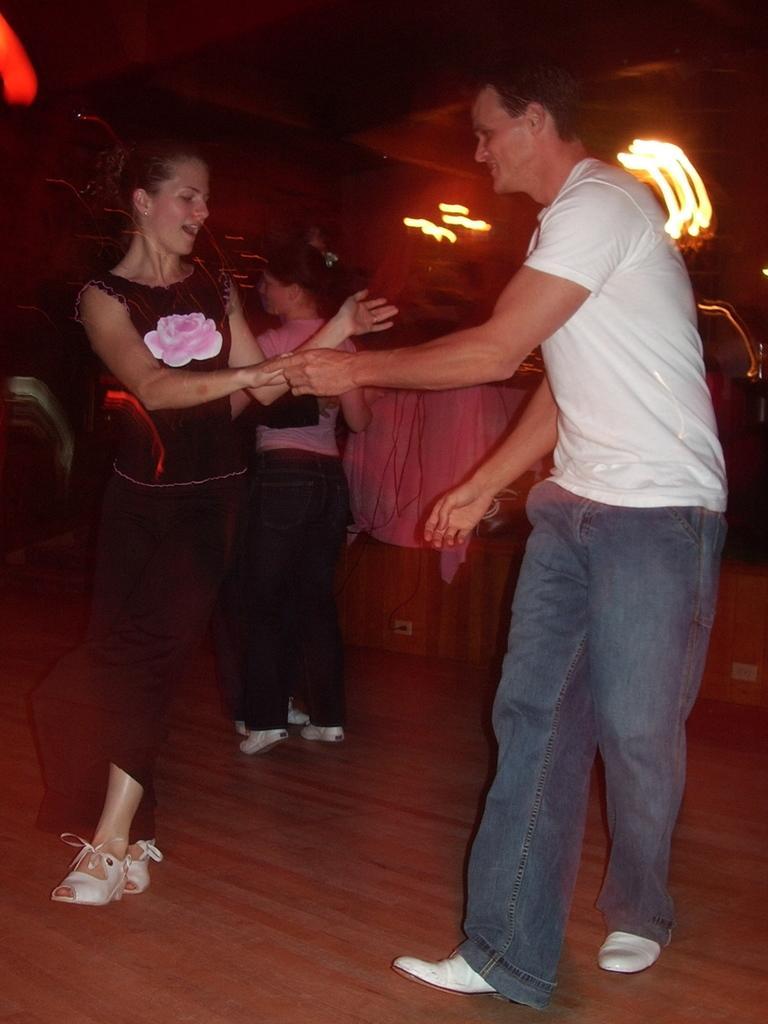Could you give a brief overview of what you see in this image? In this image there are people dancing on a wooden floor, in the background it is blurred. 